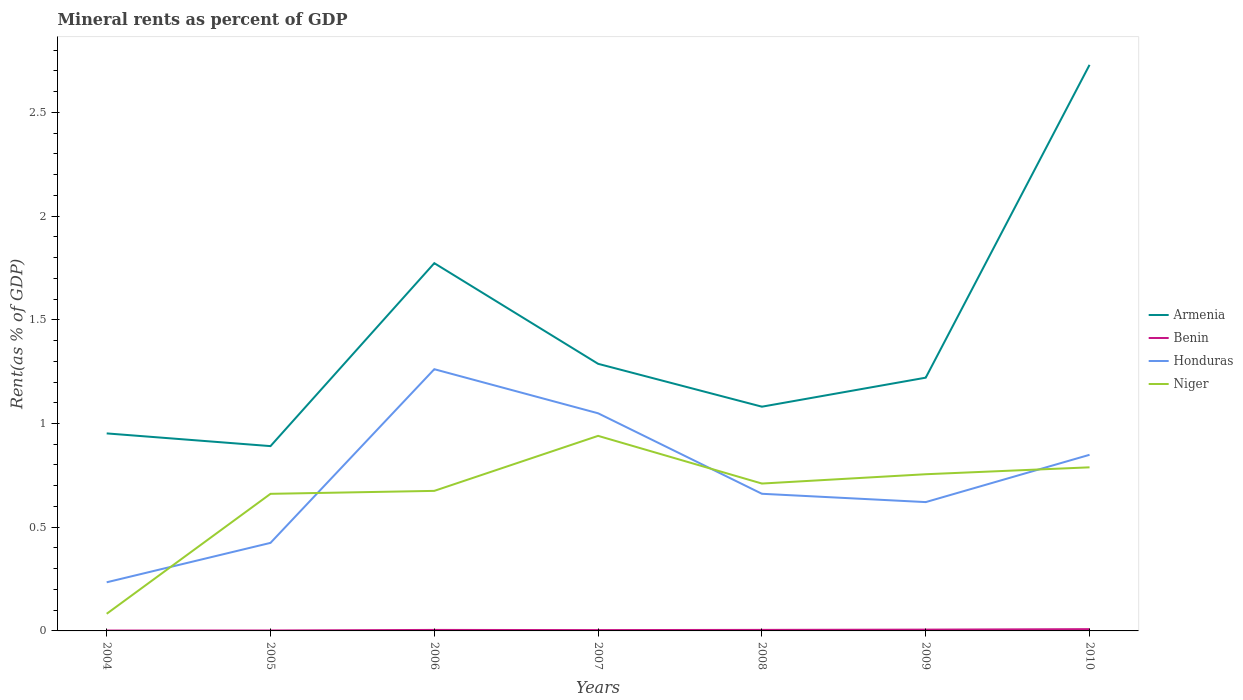How many different coloured lines are there?
Make the answer very short. 4. Across all years, what is the maximum mineral rent in Benin?
Offer a very short reply. 0. In which year was the mineral rent in Niger maximum?
Ensure brevity in your answer.  2004. What is the total mineral rent in Benin in the graph?
Ensure brevity in your answer.  -0. What is the difference between the highest and the second highest mineral rent in Armenia?
Provide a short and direct response. 1.84. Is the mineral rent in Niger strictly greater than the mineral rent in Honduras over the years?
Provide a succinct answer. No. How many lines are there?
Provide a succinct answer. 4. What is the difference between two consecutive major ticks on the Y-axis?
Give a very brief answer. 0.5. Are the values on the major ticks of Y-axis written in scientific E-notation?
Give a very brief answer. No. How are the legend labels stacked?
Offer a terse response. Vertical. What is the title of the graph?
Your answer should be compact. Mineral rents as percent of GDP. What is the label or title of the Y-axis?
Offer a terse response. Rent(as % of GDP). What is the Rent(as % of GDP) in Armenia in 2004?
Keep it short and to the point. 0.95. What is the Rent(as % of GDP) of Benin in 2004?
Your answer should be compact. 0. What is the Rent(as % of GDP) in Honduras in 2004?
Your answer should be very brief. 0.23. What is the Rent(as % of GDP) in Niger in 2004?
Your answer should be very brief. 0.08. What is the Rent(as % of GDP) in Armenia in 2005?
Offer a very short reply. 0.89. What is the Rent(as % of GDP) of Benin in 2005?
Your response must be concise. 0. What is the Rent(as % of GDP) in Honduras in 2005?
Provide a succinct answer. 0.42. What is the Rent(as % of GDP) in Niger in 2005?
Provide a short and direct response. 0.66. What is the Rent(as % of GDP) of Armenia in 2006?
Provide a succinct answer. 1.77. What is the Rent(as % of GDP) of Benin in 2006?
Provide a short and direct response. 0. What is the Rent(as % of GDP) of Honduras in 2006?
Keep it short and to the point. 1.26. What is the Rent(as % of GDP) in Niger in 2006?
Ensure brevity in your answer.  0.68. What is the Rent(as % of GDP) of Armenia in 2007?
Ensure brevity in your answer.  1.29. What is the Rent(as % of GDP) of Benin in 2007?
Ensure brevity in your answer.  0. What is the Rent(as % of GDP) of Honduras in 2007?
Ensure brevity in your answer.  1.05. What is the Rent(as % of GDP) in Niger in 2007?
Keep it short and to the point. 0.94. What is the Rent(as % of GDP) of Armenia in 2008?
Your answer should be very brief. 1.08. What is the Rent(as % of GDP) of Benin in 2008?
Your answer should be compact. 0. What is the Rent(as % of GDP) in Honduras in 2008?
Offer a very short reply. 0.66. What is the Rent(as % of GDP) of Niger in 2008?
Your answer should be very brief. 0.71. What is the Rent(as % of GDP) of Armenia in 2009?
Your answer should be very brief. 1.22. What is the Rent(as % of GDP) in Benin in 2009?
Provide a short and direct response. 0.01. What is the Rent(as % of GDP) of Honduras in 2009?
Your answer should be compact. 0.62. What is the Rent(as % of GDP) in Niger in 2009?
Ensure brevity in your answer.  0.76. What is the Rent(as % of GDP) in Armenia in 2010?
Your response must be concise. 2.73. What is the Rent(as % of GDP) of Benin in 2010?
Offer a very short reply. 0.01. What is the Rent(as % of GDP) of Honduras in 2010?
Provide a short and direct response. 0.85. What is the Rent(as % of GDP) of Niger in 2010?
Your answer should be compact. 0.79. Across all years, what is the maximum Rent(as % of GDP) of Armenia?
Keep it short and to the point. 2.73. Across all years, what is the maximum Rent(as % of GDP) in Benin?
Give a very brief answer. 0.01. Across all years, what is the maximum Rent(as % of GDP) of Honduras?
Offer a terse response. 1.26. Across all years, what is the maximum Rent(as % of GDP) in Niger?
Keep it short and to the point. 0.94. Across all years, what is the minimum Rent(as % of GDP) of Armenia?
Provide a short and direct response. 0.89. Across all years, what is the minimum Rent(as % of GDP) of Benin?
Keep it short and to the point. 0. Across all years, what is the minimum Rent(as % of GDP) in Honduras?
Ensure brevity in your answer.  0.23. Across all years, what is the minimum Rent(as % of GDP) in Niger?
Make the answer very short. 0.08. What is the total Rent(as % of GDP) of Armenia in the graph?
Ensure brevity in your answer.  9.94. What is the total Rent(as % of GDP) of Benin in the graph?
Offer a terse response. 0.03. What is the total Rent(as % of GDP) of Honduras in the graph?
Ensure brevity in your answer.  5.1. What is the total Rent(as % of GDP) in Niger in the graph?
Make the answer very short. 4.61. What is the difference between the Rent(as % of GDP) in Armenia in 2004 and that in 2005?
Give a very brief answer. 0.06. What is the difference between the Rent(as % of GDP) of Benin in 2004 and that in 2005?
Your answer should be compact. -0. What is the difference between the Rent(as % of GDP) of Honduras in 2004 and that in 2005?
Keep it short and to the point. -0.19. What is the difference between the Rent(as % of GDP) in Niger in 2004 and that in 2005?
Offer a terse response. -0.58. What is the difference between the Rent(as % of GDP) of Armenia in 2004 and that in 2006?
Give a very brief answer. -0.82. What is the difference between the Rent(as % of GDP) in Benin in 2004 and that in 2006?
Give a very brief answer. -0. What is the difference between the Rent(as % of GDP) of Honduras in 2004 and that in 2006?
Your answer should be very brief. -1.03. What is the difference between the Rent(as % of GDP) of Niger in 2004 and that in 2006?
Keep it short and to the point. -0.59. What is the difference between the Rent(as % of GDP) in Armenia in 2004 and that in 2007?
Your answer should be very brief. -0.34. What is the difference between the Rent(as % of GDP) in Benin in 2004 and that in 2007?
Provide a succinct answer. -0. What is the difference between the Rent(as % of GDP) of Honduras in 2004 and that in 2007?
Your answer should be very brief. -0.81. What is the difference between the Rent(as % of GDP) in Niger in 2004 and that in 2007?
Your answer should be compact. -0.86. What is the difference between the Rent(as % of GDP) of Armenia in 2004 and that in 2008?
Keep it short and to the point. -0.13. What is the difference between the Rent(as % of GDP) in Benin in 2004 and that in 2008?
Give a very brief answer. -0. What is the difference between the Rent(as % of GDP) of Honduras in 2004 and that in 2008?
Provide a succinct answer. -0.43. What is the difference between the Rent(as % of GDP) in Niger in 2004 and that in 2008?
Make the answer very short. -0.63. What is the difference between the Rent(as % of GDP) in Armenia in 2004 and that in 2009?
Your answer should be very brief. -0.27. What is the difference between the Rent(as % of GDP) of Benin in 2004 and that in 2009?
Your answer should be very brief. -0. What is the difference between the Rent(as % of GDP) in Honduras in 2004 and that in 2009?
Offer a terse response. -0.39. What is the difference between the Rent(as % of GDP) of Niger in 2004 and that in 2009?
Give a very brief answer. -0.67. What is the difference between the Rent(as % of GDP) of Armenia in 2004 and that in 2010?
Provide a succinct answer. -1.78. What is the difference between the Rent(as % of GDP) in Benin in 2004 and that in 2010?
Your answer should be very brief. -0.01. What is the difference between the Rent(as % of GDP) of Honduras in 2004 and that in 2010?
Your answer should be compact. -0.61. What is the difference between the Rent(as % of GDP) in Niger in 2004 and that in 2010?
Ensure brevity in your answer.  -0.71. What is the difference between the Rent(as % of GDP) in Armenia in 2005 and that in 2006?
Your answer should be very brief. -0.88. What is the difference between the Rent(as % of GDP) in Benin in 2005 and that in 2006?
Your answer should be very brief. -0. What is the difference between the Rent(as % of GDP) of Honduras in 2005 and that in 2006?
Offer a terse response. -0.84. What is the difference between the Rent(as % of GDP) of Niger in 2005 and that in 2006?
Ensure brevity in your answer.  -0.01. What is the difference between the Rent(as % of GDP) in Armenia in 2005 and that in 2007?
Keep it short and to the point. -0.4. What is the difference between the Rent(as % of GDP) of Benin in 2005 and that in 2007?
Give a very brief answer. -0. What is the difference between the Rent(as % of GDP) of Honduras in 2005 and that in 2007?
Your answer should be very brief. -0.62. What is the difference between the Rent(as % of GDP) in Niger in 2005 and that in 2007?
Provide a succinct answer. -0.28. What is the difference between the Rent(as % of GDP) of Armenia in 2005 and that in 2008?
Provide a short and direct response. -0.19. What is the difference between the Rent(as % of GDP) in Benin in 2005 and that in 2008?
Your answer should be compact. -0. What is the difference between the Rent(as % of GDP) in Honduras in 2005 and that in 2008?
Offer a terse response. -0.24. What is the difference between the Rent(as % of GDP) of Niger in 2005 and that in 2008?
Ensure brevity in your answer.  -0.05. What is the difference between the Rent(as % of GDP) in Armenia in 2005 and that in 2009?
Make the answer very short. -0.33. What is the difference between the Rent(as % of GDP) in Benin in 2005 and that in 2009?
Give a very brief answer. -0. What is the difference between the Rent(as % of GDP) in Honduras in 2005 and that in 2009?
Ensure brevity in your answer.  -0.2. What is the difference between the Rent(as % of GDP) in Niger in 2005 and that in 2009?
Offer a very short reply. -0.09. What is the difference between the Rent(as % of GDP) of Armenia in 2005 and that in 2010?
Your answer should be very brief. -1.84. What is the difference between the Rent(as % of GDP) in Benin in 2005 and that in 2010?
Make the answer very short. -0.01. What is the difference between the Rent(as % of GDP) in Honduras in 2005 and that in 2010?
Your answer should be very brief. -0.42. What is the difference between the Rent(as % of GDP) in Niger in 2005 and that in 2010?
Make the answer very short. -0.13. What is the difference between the Rent(as % of GDP) of Armenia in 2006 and that in 2007?
Offer a terse response. 0.49. What is the difference between the Rent(as % of GDP) of Benin in 2006 and that in 2007?
Ensure brevity in your answer.  0. What is the difference between the Rent(as % of GDP) in Honduras in 2006 and that in 2007?
Your answer should be very brief. 0.21. What is the difference between the Rent(as % of GDP) of Niger in 2006 and that in 2007?
Provide a short and direct response. -0.27. What is the difference between the Rent(as % of GDP) in Armenia in 2006 and that in 2008?
Offer a terse response. 0.69. What is the difference between the Rent(as % of GDP) of Benin in 2006 and that in 2008?
Your answer should be compact. -0. What is the difference between the Rent(as % of GDP) in Honduras in 2006 and that in 2008?
Provide a short and direct response. 0.6. What is the difference between the Rent(as % of GDP) of Niger in 2006 and that in 2008?
Offer a terse response. -0.04. What is the difference between the Rent(as % of GDP) in Armenia in 2006 and that in 2009?
Provide a short and direct response. 0.55. What is the difference between the Rent(as % of GDP) of Benin in 2006 and that in 2009?
Your answer should be compact. -0. What is the difference between the Rent(as % of GDP) in Honduras in 2006 and that in 2009?
Offer a terse response. 0.64. What is the difference between the Rent(as % of GDP) of Niger in 2006 and that in 2009?
Provide a short and direct response. -0.08. What is the difference between the Rent(as % of GDP) of Armenia in 2006 and that in 2010?
Provide a succinct answer. -0.96. What is the difference between the Rent(as % of GDP) in Benin in 2006 and that in 2010?
Ensure brevity in your answer.  -0. What is the difference between the Rent(as % of GDP) of Honduras in 2006 and that in 2010?
Offer a terse response. 0.41. What is the difference between the Rent(as % of GDP) in Niger in 2006 and that in 2010?
Give a very brief answer. -0.11. What is the difference between the Rent(as % of GDP) of Armenia in 2007 and that in 2008?
Your answer should be compact. 0.21. What is the difference between the Rent(as % of GDP) in Benin in 2007 and that in 2008?
Offer a very short reply. -0. What is the difference between the Rent(as % of GDP) of Honduras in 2007 and that in 2008?
Your response must be concise. 0.39. What is the difference between the Rent(as % of GDP) in Niger in 2007 and that in 2008?
Provide a succinct answer. 0.23. What is the difference between the Rent(as % of GDP) in Armenia in 2007 and that in 2009?
Keep it short and to the point. 0.07. What is the difference between the Rent(as % of GDP) of Benin in 2007 and that in 2009?
Your response must be concise. -0. What is the difference between the Rent(as % of GDP) of Honduras in 2007 and that in 2009?
Ensure brevity in your answer.  0.43. What is the difference between the Rent(as % of GDP) of Niger in 2007 and that in 2009?
Your response must be concise. 0.18. What is the difference between the Rent(as % of GDP) in Armenia in 2007 and that in 2010?
Offer a very short reply. -1.44. What is the difference between the Rent(as % of GDP) in Benin in 2007 and that in 2010?
Keep it short and to the point. -0. What is the difference between the Rent(as % of GDP) in Honduras in 2007 and that in 2010?
Your answer should be very brief. 0.2. What is the difference between the Rent(as % of GDP) of Niger in 2007 and that in 2010?
Give a very brief answer. 0.15. What is the difference between the Rent(as % of GDP) of Armenia in 2008 and that in 2009?
Provide a succinct answer. -0.14. What is the difference between the Rent(as % of GDP) of Benin in 2008 and that in 2009?
Offer a very short reply. -0. What is the difference between the Rent(as % of GDP) of Honduras in 2008 and that in 2009?
Your answer should be compact. 0.04. What is the difference between the Rent(as % of GDP) in Niger in 2008 and that in 2009?
Your response must be concise. -0.04. What is the difference between the Rent(as % of GDP) of Armenia in 2008 and that in 2010?
Provide a succinct answer. -1.65. What is the difference between the Rent(as % of GDP) of Benin in 2008 and that in 2010?
Your answer should be very brief. -0. What is the difference between the Rent(as % of GDP) in Honduras in 2008 and that in 2010?
Provide a succinct answer. -0.19. What is the difference between the Rent(as % of GDP) of Niger in 2008 and that in 2010?
Your answer should be very brief. -0.08. What is the difference between the Rent(as % of GDP) in Armenia in 2009 and that in 2010?
Your response must be concise. -1.51. What is the difference between the Rent(as % of GDP) in Benin in 2009 and that in 2010?
Offer a very short reply. -0. What is the difference between the Rent(as % of GDP) of Honduras in 2009 and that in 2010?
Provide a short and direct response. -0.23. What is the difference between the Rent(as % of GDP) in Niger in 2009 and that in 2010?
Provide a short and direct response. -0.03. What is the difference between the Rent(as % of GDP) in Armenia in 2004 and the Rent(as % of GDP) in Benin in 2005?
Provide a succinct answer. 0.95. What is the difference between the Rent(as % of GDP) of Armenia in 2004 and the Rent(as % of GDP) of Honduras in 2005?
Ensure brevity in your answer.  0.53. What is the difference between the Rent(as % of GDP) of Armenia in 2004 and the Rent(as % of GDP) of Niger in 2005?
Ensure brevity in your answer.  0.29. What is the difference between the Rent(as % of GDP) of Benin in 2004 and the Rent(as % of GDP) of Honduras in 2005?
Offer a terse response. -0.42. What is the difference between the Rent(as % of GDP) in Benin in 2004 and the Rent(as % of GDP) in Niger in 2005?
Provide a short and direct response. -0.66. What is the difference between the Rent(as % of GDP) in Honduras in 2004 and the Rent(as % of GDP) in Niger in 2005?
Offer a terse response. -0.43. What is the difference between the Rent(as % of GDP) of Armenia in 2004 and the Rent(as % of GDP) of Benin in 2006?
Provide a succinct answer. 0.95. What is the difference between the Rent(as % of GDP) in Armenia in 2004 and the Rent(as % of GDP) in Honduras in 2006?
Offer a very short reply. -0.31. What is the difference between the Rent(as % of GDP) in Armenia in 2004 and the Rent(as % of GDP) in Niger in 2006?
Keep it short and to the point. 0.28. What is the difference between the Rent(as % of GDP) in Benin in 2004 and the Rent(as % of GDP) in Honduras in 2006?
Make the answer very short. -1.26. What is the difference between the Rent(as % of GDP) of Benin in 2004 and the Rent(as % of GDP) of Niger in 2006?
Your answer should be compact. -0.67. What is the difference between the Rent(as % of GDP) of Honduras in 2004 and the Rent(as % of GDP) of Niger in 2006?
Offer a very short reply. -0.44. What is the difference between the Rent(as % of GDP) of Armenia in 2004 and the Rent(as % of GDP) of Benin in 2007?
Offer a very short reply. 0.95. What is the difference between the Rent(as % of GDP) of Armenia in 2004 and the Rent(as % of GDP) of Honduras in 2007?
Keep it short and to the point. -0.1. What is the difference between the Rent(as % of GDP) of Armenia in 2004 and the Rent(as % of GDP) of Niger in 2007?
Your answer should be very brief. 0.01. What is the difference between the Rent(as % of GDP) in Benin in 2004 and the Rent(as % of GDP) in Honduras in 2007?
Offer a very short reply. -1.05. What is the difference between the Rent(as % of GDP) of Benin in 2004 and the Rent(as % of GDP) of Niger in 2007?
Keep it short and to the point. -0.94. What is the difference between the Rent(as % of GDP) of Honduras in 2004 and the Rent(as % of GDP) of Niger in 2007?
Your response must be concise. -0.71. What is the difference between the Rent(as % of GDP) in Armenia in 2004 and the Rent(as % of GDP) in Benin in 2008?
Offer a terse response. 0.95. What is the difference between the Rent(as % of GDP) in Armenia in 2004 and the Rent(as % of GDP) in Honduras in 2008?
Your response must be concise. 0.29. What is the difference between the Rent(as % of GDP) in Armenia in 2004 and the Rent(as % of GDP) in Niger in 2008?
Offer a very short reply. 0.24. What is the difference between the Rent(as % of GDP) of Benin in 2004 and the Rent(as % of GDP) of Honduras in 2008?
Offer a very short reply. -0.66. What is the difference between the Rent(as % of GDP) of Benin in 2004 and the Rent(as % of GDP) of Niger in 2008?
Your response must be concise. -0.71. What is the difference between the Rent(as % of GDP) in Honduras in 2004 and the Rent(as % of GDP) in Niger in 2008?
Provide a succinct answer. -0.48. What is the difference between the Rent(as % of GDP) of Armenia in 2004 and the Rent(as % of GDP) of Benin in 2009?
Offer a terse response. 0.95. What is the difference between the Rent(as % of GDP) of Armenia in 2004 and the Rent(as % of GDP) of Honduras in 2009?
Ensure brevity in your answer.  0.33. What is the difference between the Rent(as % of GDP) in Armenia in 2004 and the Rent(as % of GDP) in Niger in 2009?
Keep it short and to the point. 0.2. What is the difference between the Rent(as % of GDP) of Benin in 2004 and the Rent(as % of GDP) of Honduras in 2009?
Offer a terse response. -0.62. What is the difference between the Rent(as % of GDP) of Benin in 2004 and the Rent(as % of GDP) of Niger in 2009?
Your answer should be very brief. -0.75. What is the difference between the Rent(as % of GDP) in Honduras in 2004 and the Rent(as % of GDP) in Niger in 2009?
Offer a very short reply. -0.52. What is the difference between the Rent(as % of GDP) in Armenia in 2004 and the Rent(as % of GDP) in Benin in 2010?
Your answer should be very brief. 0.94. What is the difference between the Rent(as % of GDP) in Armenia in 2004 and the Rent(as % of GDP) in Honduras in 2010?
Provide a succinct answer. 0.1. What is the difference between the Rent(as % of GDP) in Armenia in 2004 and the Rent(as % of GDP) in Niger in 2010?
Provide a short and direct response. 0.16. What is the difference between the Rent(as % of GDP) of Benin in 2004 and the Rent(as % of GDP) of Honduras in 2010?
Offer a very short reply. -0.85. What is the difference between the Rent(as % of GDP) of Benin in 2004 and the Rent(as % of GDP) of Niger in 2010?
Your answer should be very brief. -0.79. What is the difference between the Rent(as % of GDP) in Honduras in 2004 and the Rent(as % of GDP) in Niger in 2010?
Make the answer very short. -0.55. What is the difference between the Rent(as % of GDP) of Armenia in 2005 and the Rent(as % of GDP) of Benin in 2006?
Keep it short and to the point. 0.89. What is the difference between the Rent(as % of GDP) of Armenia in 2005 and the Rent(as % of GDP) of Honduras in 2006?
Your answer should be compact. -0.37. What is the difference between the Rent(as % of GDP) of Armenia in 2005 and the Rent(as % of GDP) of Niger in 2006?
Make the answer very short. 0.22. What is the difference between the Rent(as % of GDP) of Benin in 2005 and the Rent(as % of GDP) of Honduras in 2006?
Provide a short and direct response. -1.26. What is the difference between the Rent(as % of GDP) in Benin in 2005 and the Rent(as % of GDP) in Niger in 2006?
Ensure brevity in your answer.  -0.67. What is the difference between the Rent(as % of GDP) in Honduras in 2005 and the Rent(as % of GDP) in Niger in 2006?
Give a very brief answer. -0.25. What is the difference between the Rent(as % of GDP) of Armenia in 2005 and the Rent(as % of GDP) of Benin in 2007?
Ensure brevity in your answer.  0.89. What is the difference between the Rent(as % of GDP) in Armenia in 2005 and the Rent(as % of GDP) in Honduras in 2007?
Provide a short and direct response. -0.16. What is the difference between the Rent(as % of GDP) of Armenia in 2005 and the Rent(as % of GDP) of Niger in 2007?
Provide a succinct answer. -0.05. What is the difference between the Rent(as % of GDP) in Benin in 2005 and the Rent(as % of GDP) in Honduras in 2007?
Make the answer very short. -1.05. What is the difference between the Rent(as % of GDP) in Benin in 2005 and the Rent(as % of GDP) in Niger in 2007?
Your answer should be compact. -0.94. What is the difference between the Rent(as % of GDP) in Honduras in 2005 and the Rent(as % of GDP) in Niger in 2007?
Offer a terse response. -0.52. What is the difference between the Rent(as % of GDP) of Armenia in 2005 and the Rent(as % of GDP) of Benin in 2008?
Offer a terse response. 0.89. What is the difference between the Rent(as % of GDP) in Armenia in 2005 and the Rent(as % of GDP) in Honduras in 2008?
Ensure brevity in your answer.  0.23. What is the difference between the Rent(as % of GDP) in Armenia in 2005 and the Rent(as % of GDP) in Niger in 2008?
Ensure brevity in your answer.  0.18. What is the difference between the Rent(as % of GDP) of Benin in 2005 and the Rent(as % of GDP) of Honduras in 2008?
Ensure brevity in your answer.  -0.66. What is the difference between the Rent(as % of GDP) in Benin in 2005 and the Rent(as % of GDP) in Niger in 2008?
Your response must be concise. -0.71. What is the difference between the Rent(as % of GDP) in Honduras in 2005 and the Rent(as % of GDP) in Niger in 2008?
Your response must be concise. -0.29. What is the difference between the Rent(as % of GDP) of Armenia in 2005 and the Rent(as % of GDP) of Benin in 2009?
Offer a very short reply. 0.88. What is the difference between the Rent(as % of GDP) in Armenia in 2005 and the Rent(as % of GDP) in Honduras in 2009?
Offer a terse response. 0.27. What is the difference between the Rent(as % of GDP) of Armenia in 2005 and the Rent(as % of GDP) of Niger in 2009?
Your answer should be very brief. 0.14. What is the difference between the Rent(as % of GDP) of Benin in 2005 and the Rent(as % of GDP) of Honduras in 2009?
Provide a succinct answer. -0.62. What is the difference between the Rent(as % of GDP) of Benin in 2005 and the Rent(as % of GDP) of Niger in 2009?
Your answer should be very brief. -0.75. What is the difference between the Rent(as % of GDP) of Honduras in 2005 and the Rent(as % of GDP) of Niger in 2009?
Make the answer very short. -0.33. What is the difference between the Rent(as % of GDP) in Armenia in 2005 and the Rent(as % of GDP) in Benin in 2010?
Make the answer very short. 0.88. What is the difference between the Rent(as % of GDP) of Armenia in 2005 and the Rent(as % of GDP) of Honduras in 2010?
Offer a very short reply. 0.04. What is the difference between the Rent(as % of GDP) in Armenia in 2005 and the Rent(as % of GDP) in Niger in 2010?
Make the answer very short. 0.1. What is the difference between the Rent(as % of GDP) of Benin in 2005 and the Rent(as % of GDP) of Honduras in 2010?
Provide a short and direct response. -0.85. What is the difference between the Rent(as % of GDP) of Benin in 2005 and the Rent(as % of GDP) of Niger in 2010?
Give a very brief answer. -0.79. What is the difference between the Rent(as % of GDP) in Honduras in 2005 and the Rent(as % of GDP) in Niger in 2010?
Offer a very short reply. -0.36. What is the difference between the Rent(as % of GDP) in Armenia in 2006 and the Rent(as % of GDP) in Benin in 2007?
Offer a very short reply. 1.77. What is the difference between the Rent(as % of GDP) of Armenia in 2006 and the Rent(as % of GDP) of Honduras in 2007?
Your response must be concise. 0.72. What is the difference between the Rent(as % of GDP) in Armenia in 2006 and the Rent(as % of GDP) in Niger in 2007?
Ensure brevity in your answer.  0.83. What is the difference between the Rent(as % of GDP) of Benin in 2006 and the Rent(as % of GDP) of Honduras in 2007?
Your response must be concise. -1.04. What is the difference between the Rent(as % of GDP) of Benin in 2006 and the Rent(as % of GDP) of Niger in 2007?
Provide a short and direct response. -0.94. What is the difference between the Rent(as % of GDP) in Honduras in 2006 and the Rent(as % of GDP) in Niger in 2007?
Make the answer very short. 0.32. What is the difference between the Rent(as % of GDP) in Armenia in 2006 and the Rent(as % of GDP) in Benin in 2008?
Provide a short and direct response. 1.77. What is the difference between the Rent(as % of GDP) of Armenia in 2006 and the Rent(as % of GDP) of Honduras in 2008?
Your response must be concise. 1.11. What is the difference between the Rent(as % of GDP) of Armenia in 2006 and the Rent(as % of GDP) of Niger in 2008?
Provide a succinct answer. 1.06. What is the difference between the Rent(as % of GDP) of Benin in 2006 and the Rent(as % of GDP) of Honduras in 2008?
Provide a succinct answer. -0.66. What is the difference between the Rent(as % of GDP) in Benin in 2006 and the Rent(as % of GDP) in Niger in 2008?
Provide a succinct answer. -0.71. What is the difference between the Rent(as % of GDP) in Honduras in 2006 and the Rent(as % of GDP) in Niger in 2008?
Offer a terse response. 0.55. What is the difference between the Rent(as % of GDP) of Armenia in 2006 and the Rent(as % of GDP) of Benin in 2009?
Your response must be concise. 1.77. What is the difference between the Rent(as % of GDP) of Armenia in 2006 and the Rent(as % of GDP) of Honduras in 2009?
Your answer should be very brief. 1.15. What is the difference between the Rent(as % of GDP) of Armenia in 2006 and the Rent(as % of GDP) of Niger in 2009?
Ensure brevity in your answer.  1.02. What is the difference between the Rent(as % of GDP) in Benin in 2006 and the Rent(as % of GDP) in Honduras in 2009?
Give a very brief answer. -0.62. What is the difference between the Rent(as % of GDP) of Benin in 2006 and the Rent(as % of GDP) of Niger in 2009?
Offer a terse response. -0.75. What is the difference between the Rent(as % of GDP) in Honduras in 2006 and the Rent(as % of GDP) in Niger in 2009?
Keep it short and to the point. 0.51. What is the difference between the Rent(as % of GDP) in Armenia in 2006 and the Rent(as % of GDP) in Benin in 2010?
Your answer should be compact. 1.76. What is the difference between the Rent(as % of GDP) of Armenia in 2006 and the Rent(as % of GDP) of Honduras in 2010?
Give a very brief answer. 0.92. What is the difference between the Rent(as % of GDP) of Armenia in 2006 and the Rent(as % of GDP) of Niger in 2010?
Provide a short and direct response. 0.98. What is the difference between the Rent(as % of GDP) in Benin in 2006 and the Rent(as % of GDP) in Honduras in 2010?
Provide a succinct answer. -0.84. What is the difference between the Rent(as % of GDP) in Benin in 2006 and the Rent(as % of GDP) in Niger in 2010?
Provide a succinct answer. -0.78. What is the difference between the Rent(as % of GDP) of Honduras in 2006 and the Rent(as % of GDP) of Niger in 2010?
Your answer should be compact. 0.47. What is the difference between the Rent(as % of GDP) in Armenia in 2007 and the Rent(as % of GDP) in Benin in 2008?
Provide a short and direct response. 1.28. What is the difference between the Rent(as % of GDP) in Armenia in 2007 and the Rent(as % of GDP) in Honduras in 2008?
Give a very brief answer. 0.63. What is the difference between the Rent(as % of GDP) of Armenia in 2007 and the Rent(as % of GDP) of Niger in 2008?
Provide a succinct answer. 0.58. What is the difference between the Rent(as % of GDP) in Benin in 2007 and the Rent(as % of GDP) in Honduras in 2008?
Give a very brief answer. -0.66. What is the difference between the Rent(as % of GDP) in Benin in 2007 and the Rent(as % of GDP) in Niger in 2008?
Ensure brevity in your answer.  -0.71. What is the difference between the Rent(as % of GDP) in Honduras in 2007 and the Rent(as % of GDP) in Niger in 2008?
Offer a very short reply. 0.34. What is the difference between the Rent(as % of GDP) of Armenia in 2007 and the Rent(as % of GDP) of Benin in 2009?
Your answer should be compact. 1.28. What is the difference between the Rent(as % of GDP) of Armenia in 2007 and the Rent(as % of GDP) of Honduras in 2009?
Make the answer very short. 0.67. What is the difference between the Rent(as % of GDP) in Armenia in 2007 and the Rent(as % of GDP) in Niger in 2009?
Keep it short and to the point. 0.53. What is the difference between the Rent(as % of GDP) in Benin in 2007 and the Rent(as % of GDP) in Honduras in 2009?
Give a very brief answer. -0.62. What is the difference between the Rent(as % of GDP) of Benin in 2007 and the Rent(as % of GDP) of Niger in 2009?
Your answer should be very brief. -0.75. What is the difference between the Rent(as % of GDP) of Honduras in 2007 and the Rent(as % of GDP) of Niger in 2009?
Provide a short and direct response. 0.29. What is the difference between the Rent(as % of GDP) of Armenia in 2007 and the Rent(as % of GDP) of Benin in 2010?
Your answer should be very brief. 1.28. What is the difference between the Rent(as % of GDP) in Armenia in 2007 and the Rent(as % of GDP) in Honduras in 2010?
Give a very brief answer. 0.44. What is the difference between the Rent(as % of GDP) in Armenia in 2007 and the Rent(as % of GDP) in Niger in 2010?
Keep it short and to the point. 0.5. What is the difference between the Rent(as % of GDP) of Benin in 2007 and the Rent(as % of GDP) of Honduras in 2010?
Offer a very short reply. -0.84. What is the difference between the Rent(as % of GDP) of Benin in 2007 and the Rent(as % of GDP) of Niger in 2010?
Keep it short and to the point. -0.78. What is the difference between the Rent(as % of GDP) in Honduras in 2007 and the Rent(as % of GDP) in Niger in 2010?
Offer a terse response. 0.26. What is the difference between the Rent(as % of GDP) of Armenia in 2008 and the Rent(as % of GDP) of Benin in 2009?
Provide a succinct answer. 1.07. What is the difference between the Rent(as % of GDP) of Armenia in 2008 and the Rent(as % of GDP) of Honduras in 2009?
Make the answer very short. 0.46. What is the difference between the Rent(as % of GDP) in Armenia in 2008 and the Rent(as % of GDP) in Niger in 2009?
Your answer should be compact. 0.33. What is the difference between the Rent(as % of GDP) in Benin in 2008 and the Rent(as % of GDP) in Honduras in 2009?
Give a very brief answer. -0.62. What is the difference between the Rent(as % of GDP) of Benin in 2008 and the Rent(as % of GDP) of Niger in 2009?
Keep it short and to the point. -0.75. What is the difference between the Rent(as % of GDP) of Honduras in 2008 and the Rent(as % of GDP) of Niger in 2009?
Your answer should be compact. -0.09. What is the difference between the Rent(as % of GDP) of Armenia in 2008 and the Rent(as % of GDP) of Benin in 2010?
Your answer should be compact. 1.07. What is the difference between the Rent(as % of GDP) in Armenia in 2008 and the Rent(as % of GDP) in Honduras in 2010?
Ensure brevity in your answer.  0.23. What is the difference between the Rent(as % of GDP) in Armenia in 2008 and the Rent(as % of GDP) in Niger in 2010?
Make the answer very short. 0.29. What is the difference between the Rent(as % of GDP) in Benin in 2008 and the Rent(as % of GDP) in Honduras in 2010?
Offer a very short reply. -0.84. What is the difference between the Rent(as % of GDP) in Benin in 2008 and the Rent(as % of GDP) in Niger in 2010?
Make the answer very short. -0.78. What is the difference between the Rent(as % of GDP) of Honduras in 2008 and the Rent(as % of GDP) of Niger in 2010?
Make the answer very short. -0.13. What is the difference between the Rent(as % of GDP) of Armenia in 2009 and the Rent(as % of GDP) of Benin in 2010?
Provide a short and direct response. 1.21. What is the difference between the Rent(as % of GDP) in Armenia in 2009 and the Rent(as % of GDP) in Honduras in 2010?
Keep it short and to the point. 0.37. What is the difference between the Rent(as % of GDP) in Armenia in 2009 and the Rent(as % of GDP) in Niger in 2010?
Give a very brief answer. 0.43. What is the difference between the Rent(as % of GDP) of Benin in 2009 and the Rent(as % of GDP) of Honduras in 2010?
Ensure brevity in your answer.  -0.84. What is the difference between the Rent(as % of GDP) in Benin in 2009 and the Rent(as % of GDP) in Niger in 2010?
Provide a short and direct response. -0.78. What is the difference between the Rent(as % of GDP) of Honduras in 2009 and the Rent(as % of GDP) of Niger in 2010?
Give a very brief answer. -0.17. What is the average Rent(as % of GDP) in Armenia per year?
Your response must be concise. 1.42. What is the average Rent(as % of GDP) of Benin per year?
Keep it short and to the point. 0. What is the average Rent(as % of GDP) of Honduras per year?
Your answer should be compact. 0.73. What is the average Rent(as % of GDP) of Niger per year?
Offer a very short reply. 0.66. In the year 2004, what is the difference between the Rent(as % of GDP) in Armenia and Rent(as % of GDP) in Benin?
Your answer should be very brief. 0.95. In the year 2004, what is the difference between the Rent(as % of GDP) of Armenia and Rent(as % of GDP) of Honduras?
Offer a terse response. 0.72. In the year 2004, what is the difference between the Rent(as % of GDP) in Armenia and Rent(as % of GDP) in Niger?
Offer a terse response. 0.87. In the year 2004, what is the difference between the Rent(as % of GDP) of Benin and Rent(as % of GDP) of Honduras?
Give a very brief answer. -0.23. In the year 2004, what is the difference between the Rent(as % of GDP) of Benin and Rent(as % of GDP) of Niger?
Ensure brevity in your answer.  -0.08. In the year 2004, what is the difference between the Rent(as % of GDP) of Honduras and Rent(as % of GDP) of Niger?
Your response must be concise. 0.15. In the year 2005, what is the difference between the Rent(as % of GDP) in Armenia and Rent(as % of GDP) in Benin?
Your answer should be very brief. 0.89. In the year 2005, what is the difference between the Rent(as % of GDP) in Armenia and Rent(as % of GDP) in Honduras?
Ensure brevity in your answer.  0.47. In the year 2005, what is the difference between the Rent(as % of GDP) of Armenia and Rent(as % of GDP) of Niger?
Give a very brief answer. 0.23. In the year 2005, what is the difference between the Rent(as % of GDP) of Benin and Rent(as % of GDP) of Honduras?
Offer a terse response. -0.42. In the year 2005, what is the difference between the Rent(as % of GDP) in Benin and Rent(as % of GDP) in Niger?
Your response must be concise. -0.66. In the year 2005, what is the difference between the Rent(as % of GDP) of Honduras and Rent(as % of GDP) of Niger?
Your answer should be very brief. -0.24. In the year 2006, what is the difference between the Rent(as % of GDP) of Armenia and Rent(as % of GDP) of Benin?
Provide a short and direct response. 1.77. In the year 2006, what is the difference between the Rent(as % of GDP) of Armenia and Rent(as % of GDP) of Honduras?
Keep it short and to the point. 0.51. In the year 2006, what is the difference between the Rent(as % of GDP) in Armenia and Rent(as % of GDP) in Niger?
Provide a succinct answer. 1.1. In the year 2006, what is the difference between the Rent(as % of GDP) in Benin and Rent(as % of GDP) in Honduras?
Your response must be concise. -1.26. In the year 2006, what is the difference between the Rent(as % of GDP) in Benin and Rent(as % of GDP) in Niger?
Keep it short and to the point. -0.67. In the year 2006, what is the difference between the Rent(as % of GDP) of Honduras and Rent(as % of GDP) of Niger?
Provide a short and direct response. 0.59. In the year 2007, what is the difference between the Rent(as % of GDP) in Armenia and Rent(as % of GDP) in Benin?
Keep it short and to the point. 1.28. In the year 2007, what is the difference between the Rent(as % of GDP) in Armenia and Rent(as % of GDP) in Honduras?
Ensure brevity in your answer.  0.24. In the year 2007, what is the difference between the Rent(as % of GDP) of Armenia and Rent(as % of GDP) of Niger?
Make the answer very short. 0.35. In the year 2007, what is the difference between the Rent(as % of GDP) of Benin and Rent(as % of GDP) of Honduras?
Make the answer very short. -1.05. In the year 2007, what is the difference between the Rent(as % of GDP) of Benin and Rent(as % of GDP) of Niger?
Your answer should be very brief. -0.94. In the year 2007, what is the difference between the Rent(as % of GDP) in Honduras and Rent(as % of GDP) in Niger?
Offer a very short reply. 0.11. In the year 2008, what is the difference between the Rent(as % of GDP) in Armenia and Rent(as % of GDP) in Benin?
Offer a terse response. 1.08. In the year 2008, what is the difference between the Rent(as % of GDP) of Armenia and Rent(as % of GDP) of Honduras?
Your response must be concise. 0.42. In the year 2008, what is the difference between the Rent(as % of GDP) of Armenia and Rent(as % of GDP) of Niger?
Offer a terse response. 0.37. In the year 2008, what is the difference between the Rent(as % of GDP) in Benin and Rent(as % of GDP) in Honduras?
Your answer should be compact. -0.66. In the year 2008, what is the difference between the Rent(as % of GDP) of Benin and Rent(as % of GDP) of Niger?
Provide a short and direct response. -0.71. In the year 2008, what is the difference between the Rent(as % of GDP) in Honduras and Rent(as % of GDP) in Niger?
Your answer should be compact. -0.05. In the year 2009, what is the difference between the Rent(as % of GDP) of Armenia and Rent(as % of GDP) of Benin?
Make the answer very short. 1.21. In the year 2009, what is the difference between the Rent(as % of GDP) of Armenia and Rent(as % of GDP) of Honduras?
Provide a succinct answer. 0.6. In the year 2009, what is the difference between the Rent(as % of GDP) in Armenia and Rent(as % of GDP) in Niger?
Provide a succinct answer. 0.47. In the year 2009, what is the difference between the Rent(as % of GDP) in Benin and Rent(as % of GDP) in Honduras?
Give a very brief answer. -0.61. In the year 2009, what is the difference between the Rent(as % of GDP) in Benin and Rent(as % of GDP) in Niger?
Your answer should be compact. -0.75. In the year 2009, what is the difference between the Rent(as % of GDP) in Honduras and Rent(as % of GDP) in Niger?
Make the answer very short. -0.13. In the year 2010, what is the difference between the Rent(as % of GDP) of Armenia and Rent(as % of GDP) of Benin?
Your answer should be compact. 2.72. In the year 2010, what is the difference between the Rent(as % of GDP) of Armenia and Rent(as % of GDP) of Honduras?
Make the answer very short. 1.88. In the year 2010, what is the difference between the Rent(as % of GDP) in Armenia and Rent(as % of GDP) in Niger?
Give a very brief answer. 1.94. In the year 2010, what is the difference between the Rent(as % of GDP) in Benin and Rent(as % of GDP) in Honduras?
Offer a very short reply. -0.84. In the year 2010, what is the difference between the Rent(as % of GDP) in Benin and Rent(as % of GDP) in Niger?
Ensure brevity in your answer.  -0.78. In the year 2010, what is the difference between the Rent(as % of GDP) of Honduras and Rent(as % of GDP) of Niger?
Provide a short and direct response. 0.06. What is the ratio of the Rent(as % of GDP) of Armenia in 2004 to that in 2005?
Keep it short and to the point. 1.07. What is the ratio of the Rent(as % of GDP) of Benin in 2004 to that in 2005?
Provide a short and direct response. 0.87. What is the ratio of the Rent(as % of GDP) in Honduras in 2004 to that in 2005?
Give a very brief answer. 0.55. What is the ratio of the Rent(as % of GDP) in Armenia in 2004 to that in 2006?
Your answer should be very brief. 0.54. What is the ratio of the Rent(as % of GDP) of Benin in 2004 to that in 2006?
Provide a short and direct response. 0.38. What is the ratio of the Rent(as % of GDP) in Honduras in 2004 to that in 2006?
Make the answer very short. 0.19. What is the ratio of the Rent(as % of GDP) in Niger in 2004 to that in 2006?
Provide a short and direct response. 0.12. What is the ratio of the Rent(as % of GDP) of Armenia in 2004 to that in 2007?
Provide a short and direct response. 0.74. What is the ratio of the Rent(as % of GDP) in Benin in 2004 to that in 2007?
Provide a short and direct response. 0.45. What is the ratio of the Rent(as % of GDP) in Honduras in 2004 to that in 2007?
Your answer should be compact. 0.22. What is the ratio of the Rent(as % of GDP) in Niger in 2004 to that in 2007?
Ensure brevity in your answer.  0.09. What is the ratio of the Rent(as % of GDP) in Armenia in 2004 to that in 2008?
Your answer should be compact. 0.88. What is the ratio of the Rent(as % of GDP) in Benin in 2004 to that in 2008?
Offer a very short reply. 0.36. What is the ratio of the Rent(as % of GDP) of Honduras in 2004 to that in 2008?
Offer a very short reply. 0.35. What is the ratio of the Rent(as % of GDP) of Niger in 2004 to that in 2008?
Keep it short and to the point. 0.12. What is the ratio of the Rent(as % of GDP) of Armenia in 2004 to that in 2009?
Make the answer very short. 0.78. What is the ratio of the Rent(as % of GDP) of Benin in 2004 to that in 2009?
Your response must be concise. 0.29. What is the ratio of the Rent(as % of GDP) in Honduras in 2004 to that in 2009?
Give a very brief answer. 0.38. What is the ratio of the Rent(as % of GDP) in Niger in 2004 to that in 2009?
Give a very brief answer. 0.11. What is the ratio of the Rent(as % of GDP) in Armenia in 2004 to that in 2010?
Provide a succinct answer. 0.35. What is the ratio of the Rent(as % of GDP) of Benin in 2004 to that in 2010?
Keep it short and to the point. 0.21. What is the ratio of the Rent(as % of GDP) in Honduras in 2004 to that in 2010?
Keep it short and to the point. 0.28. What is the ratio of the Rent(as % of GDP) in Niger in 2004 to that in 2010?
Offer a very short reply. 0.1. What is the ratio of the Rent(as % of GDP) of Armenia in 2005 to that in 2006?
Give a very brief answer. 0.5. What is the ratio of the Rent(as % of GDP) in Benin in 2005 to that in 2006?
Keep it short and to the point. 0.43. What is the ratio of the Rent(as % of GDP) of Honduras in 2005 to that in 2006?
Provide a short and direct response. 0.34. What is the ratio of the Rent(as % of GDP) in Niger in 2005 to that in 2006?
Make the answer very short. 0.98. What is the ratio of the Rent(as % of GDP) in Armenia in 2005 to that in 2007?
Provide a succinct answer. 0.69. What is the ratio of the Rent(as % of GDP) in Benin in 2005 to that in 2007?
Provide a short and direct response. 0.51. What is the ratio of the Rent(as % of GDP) in Honduras in 2005 to that in 2007?
Offer a very short reply. 0.4. What is the ratio of the Rent(as % of GDP) of Niger in 2005 to that in 2007?
Make the answer very short. 0.7. What is the ratio of the Rent(as % of GDP) of Armenia in 2005 to that in 2008?
Make the answer very short. 0.82. What is the ratio of the Rent(as % of GDP) of Benin in 2005 to that in 2008?
Offer a very short reply. 0.42. What is the ratio of the Rent(as % of GDP) in Honduras in 2005 to that in 2008?
Offer a very short reply. 0.64. What is the ratio of the Rent(as % of GDP) of Niger in 2005 to that in 2008?
Ensure brevity in your answer.  0.93. What is the ratio of the Rent(as % of GDP) in Armenia in 2005 to that in 2009?
Provide a short and direct response. 0.73. What is the ratio of the Rent(as % of GDP) of Benin in 2005 to that in 2009?
Your response must be concise. 0.33. What is the ratio of the Rent(as % of GDP) in Honduras in 2005 to that in 2009?
Give a very brief answer. 0.68. What is the ratio of the Rent(as % of GDP) of Armenia in 2005 to that in 2010?
Make the answer very short. 0.33. What is the ratio of the Rent(as % of GDP) in Benin in 2005 to that in 2010?
Keep it short and to the point. 0.24. What is the ratio of the Rent(as % of GDP) in Niger in 2005 to that in 2010?
Provide a short and direct response. 0.84. What is the ratio of the Rent(as % of GDP) of Armenia in 2006 to that in 2007?
Offer a very short reply. 1.38. What is the ratio of the Rent(as % of GDP) in Benin in 2006 to that in 2007?
Offer a terse response. 1.18. What is the ratio of the Rent(as % of GDP) of Honduras in 2006 to that in 2007?
Your response must be concise. 1.2. What is the ratio of the Rent(as % of GDP) in Niger in 2006 to that in 2007?
Your answer should be compact. 0.72. What is the ratio of the Rent(as % of GDP) in Armenia in 2006 to that in 2008?
Keep it short and to the point. 1.64. What is the ratio of the Rent(as % of GDP) of Benin in 2006 to that in 2008?
Your answer should be very brief. 0.96. What is the ratio of the Rent(as % of GDP) of Honduras in 2006 to that in 2008?
Keep it short and to the point. 1.91. What is the ratio of the Rent(as % of GDP) of Niger in 2006 to that in 2008?
Your answer should be compact. 0.95. What is the ratio of the Rent(as % of GDP) of Armenia in 2006 to that in 2009?
Your answer should be compact. 1.45. What is the ratio of the Rent(as % of GDP) of Benin in 2006 to that in 2009?
Provide a succinct answer. 0.77. What is the ratio of the Rent(as % of GDP) in Honduras in 2006 to that in 2009?
Make the answer very short. 2.03. What is the ratio of the Rent(as % of GDP) in Niger in 2006 to that in 2009?
Your response must be concise. 0.89. What is the ratio of the Rent(as % of GDP) in Armenia in 2006 to that in 2010?
Offer a terse response. 0.65. What is the ratio of the Rent(as % of GDP) in Benin in 2006 to that in 2010?
Make the answer very short. 0.56. What is the ratio of the Rent(as % of GDP) in Honduras in 2006 to that in 2010?
Provide a succinct answer. 1.49. What is the ratio of the Rent(as % of GDP) of Niger in 2006 to that in 2010?
Keep it short and to the point. 0.86. What is the ratio of the Rent(as % of GDP) in Armenia in 2007 to that in 2008?
Provide a succinct answer. 1.19. What is the ratio of the Rent(as % of GDP) in Benin in 2007 to that in 2008?
Keep it short and to the point. 0.81. What is the ratio of the Rent(as % of GDP) of Honduras in 2007 to that in 2008?
Keep it short and to the point. 1.59. What is the ratio of the Rent(as % of GDP) of Niger in 2007 to that in 2008?
Keep it short and to the point. 1.32. What is the ratio of the Rent(as % of GDP) in Armenia in 2007 to that in 2009?
Ensure brevity in your answer.  1.05. What is the ratio of the Rent(as % of GDP) in Benin in 2007 to that in 2009?
Offer a very short reply. 0.65. What is the ratio of the Rent(as % of GDP) in Honduras in 2007 to that in 2009?
Your answer should be compact. 1.69. What is the ratio of the Rent(as % of GDP) of Niger in 2007 to that in 2009?
Offer a very short reply. 1.24. What is the ratio of the Rent(as % of GDP) in Armenia in 2007 to that in 2010?
Keep it short and to the point. 0.47. What is the ratio of the Rent(as % of GDP) of Benin in 2007 to that in 2010?
Keep it short and to the point. 0.47. What is the ratio of the Rent(as % of GDP) of Honduras in 2007 to that in 2010?
Offer a very short reply. 1.24. What is the ratio of the Rent(as % of GDP) in Niger in 2007 to that in 2010?
Give a very brief answer. 1.19. What is the ratio of the Rent(as % of GDP) in Armenia in 2008 to that in 2009?
Your answer should be compact. 0.89. What is the ratio of the Rent(as % of GDP) in Benin in 2008 to that in 2009?
Ensure brevity in your answer.  0.8. What is the ratio of the Rent(as % of GDP) in Honduras in 2008 to that in 2009?
Offer a very short reply. 1.06. What is the ratio of the Rent(as % of GDP) in Niger in 2008 to that in 2009?
Your answer should be compact. 0.94. What is the ratio of the Rent(as % of GDP) in Armenia in 2008 to that in 2010?
Your answer should be very brief. 0.4. What is the ratio of the Rent(as % of GDP) of Benin in 2008 to that in 2010?
Your answer should be compact. 0.58. What is the ratio of the Rent(as % of GDP) of Honduras in 2008 to that in 2010?
Provide a succinct answer. 0.78. What is the ratio of the Rent(as % of GDP) in Niger in 2008 to that in 2010?
Your response must be concise. 0.9. What is the ratio of the Rent(as % of GDP) in Armenia in 2009 to that in 2010?
Give a very brief answer. 0.45. What is the ratio of the Rent(as % of GDP) of Benin in 2009 to that in 2010?
Your answer should be compact. 0.72. What is the ratio of the Rent(as % of GDP) in Honduras in 2009 to that in 2010?
Provide a short and direct response. 0.73. What is the ratio of the Rent(as % of GDP) in Niger in 2009 to that in 2010?
Provide a succinct answer. 0.96. What is the difference between the highest and the second highest Rent(as % of GDP) in Armenia?
Your answer should be compact. 0.96. What is the difference between the highest and the second highest Rent(as % of GDP) in Benin?
Make the answer very short. 0. What is the difference between the highest and the second highest Rent(as % of GDP) in Honduras?
Offer a very short reply. 0.21. What is the difference between the highest and the second highest Rent(as % of GDP) in Niger?
Your answer should be compact. 0.15. What is the difference between the highest and the lowest Rent(as % of GDP) in Armenia?
Make the answer very short. 1.84. What is the difference between the highest and the lowest Rent(as % of GDP) in Benin?
Offer a terse response. 0.01. What is the difference between the highest and the lowest Rent(as % of GDP) in Honduras?
Provide a succinct answer. 1.03. What is the difference between the highest and the lowest Rent(as % of GDP) in Niger?
Your answer should be compact. 0.86. 